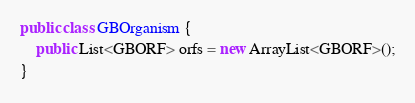<code> <loc_0><loc_0><loc_500><loc_500><_Java_>public class GBOrganism {
	public List<GBORF> orfs = new ArrayList<GBORF>();
}
</code> 